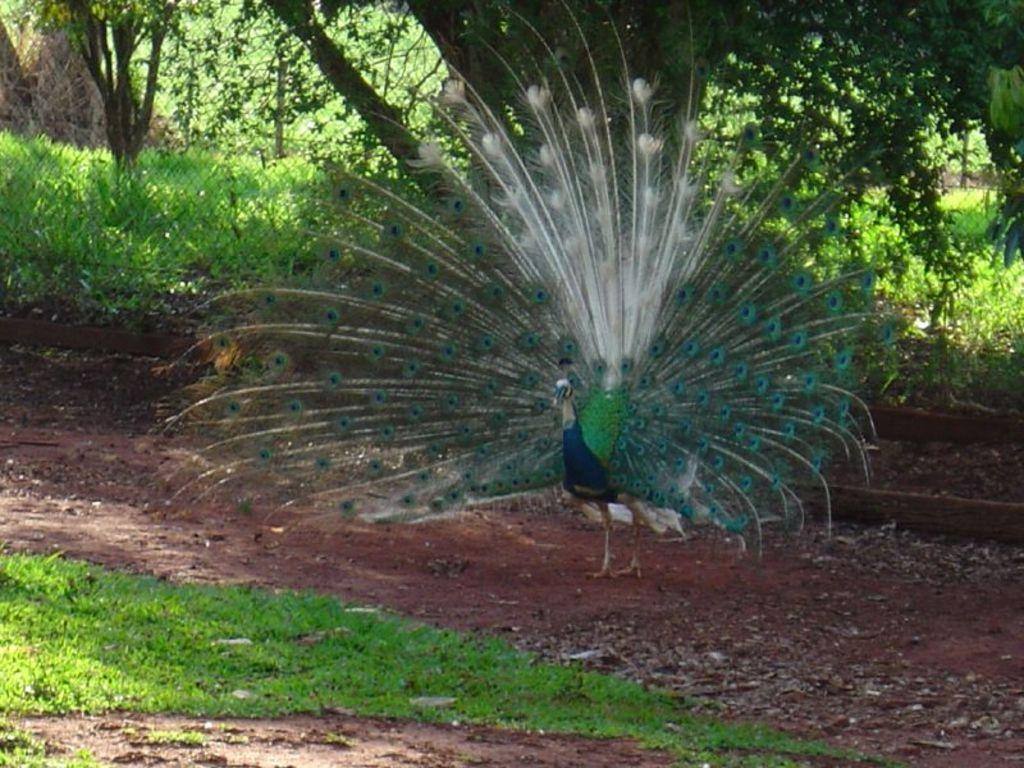What type of animal is in the image? There is a peacock in the image. Where is the peacock located? The peacock is on a surface in the image. What type of vegetation can be seen in the image? There are trees and green grass in the image. What country is the giraffe from in the image? There is no giraffe present in the image, so it is not possible to determine the country it might be from. 